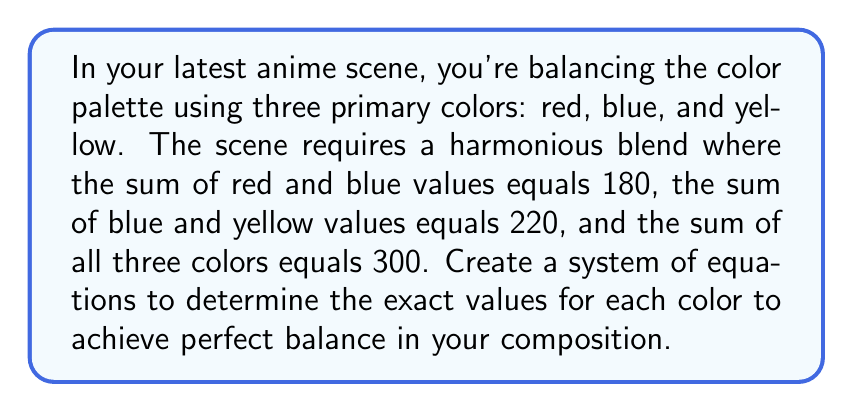Give your solution to this math problem. Let's approach this step-by-step:

1) First, let's define our variables:
   Let $r$ = red value
   Let $b$ = blue value
   Let $y$ = yellow value

2) Now, we can set up our system of equations based on the given information:
   $$\begin{cases}
   r + b = 180 & \text{(Equation 1)}\\
   b + y = 220 & \text{(Equation 2)}\\
   r + b + y = 300 & \text{(Equation 3)}
   \end{cases}$$

3) We can solve this system using substitution. Let's start by expressing $r$ in terms of $b$ from Equation 1:
   $r = 180 - b$ (Equation 4)

4) Substitute this into Equation 3:
   $(180 - b) + b + y = 300$
   $180 + y = 300$
   $y = 120$ (Equation 5)

5) Now substitute $y = 120$ into Equation 2:
   $b + 120 = 220$
   $b = 100$

6) Finally, we can find $r$ by substituting $b = 100$ into Equation 4:
   $r = 180 - 100 = 80$

7) Let's verify our solution satisfies all equations:
   Equation 1: $80 + 100 = 180$ ✓
   Equation 2: $100 + 120 = 220$ ✓
   Equation 3: $80 + 100 + 120 = 300$ ✓

Therefore, the balanced color values are: red = 80, blue = 100, and yellow = 120.
Answer: $r = 80$, $b = 100$, $y = 120$ 